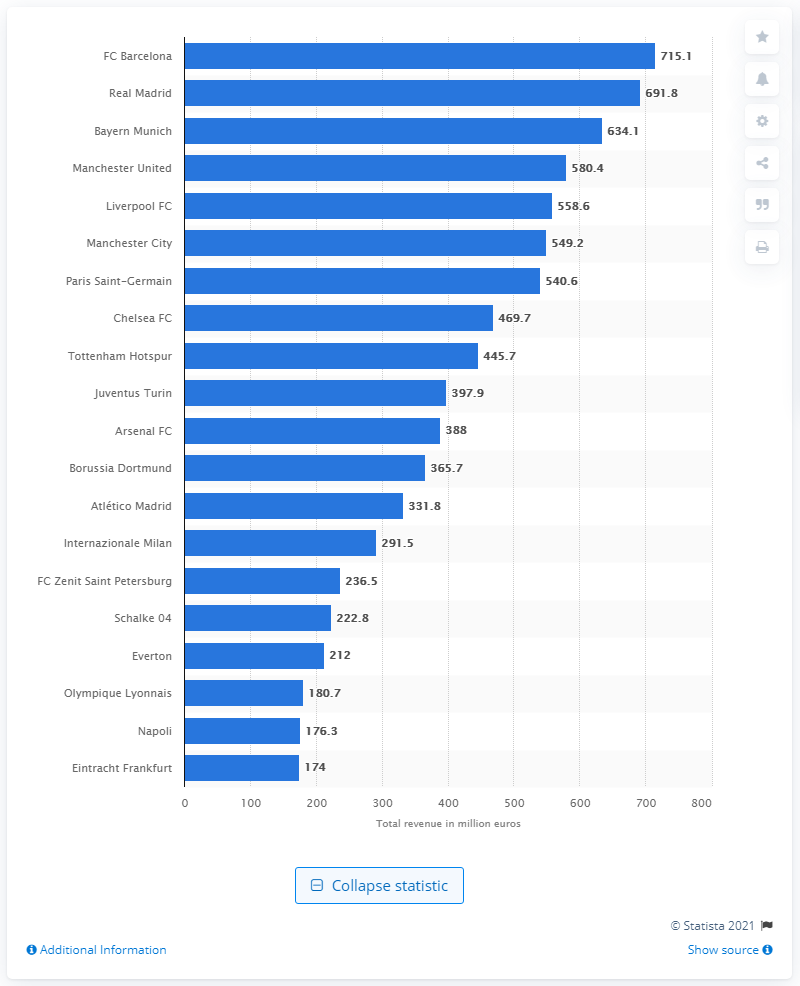Give some essential details in this illustration. During the 2019/2020 season, Barcelona generated a revenue of 715.1 million euros. Real Madrid has the most appearances in the Champions League, making them the team to beat in this prestigious competition. 